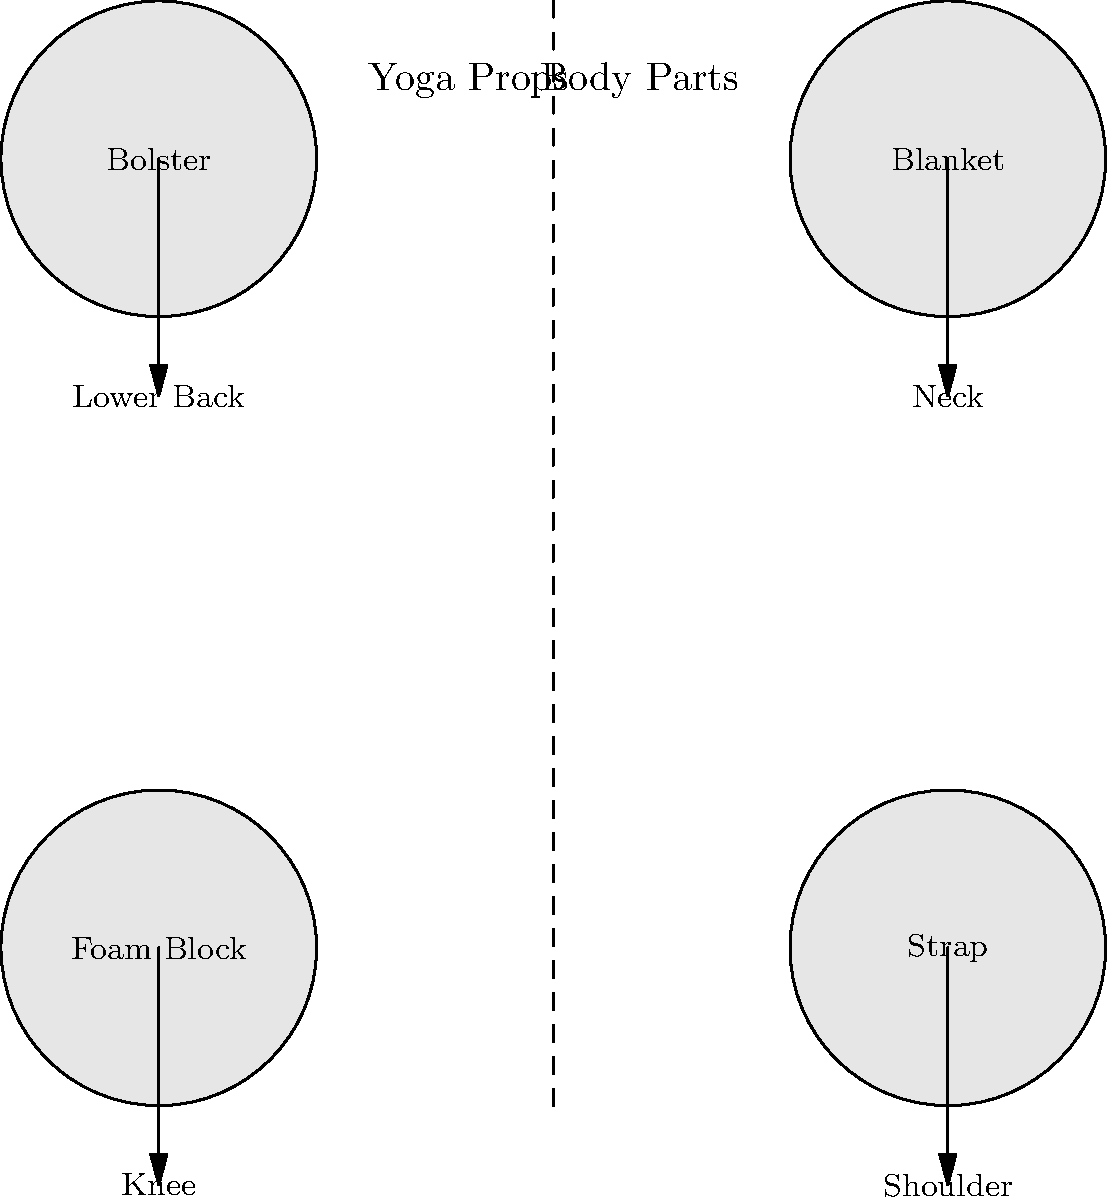Match the yoga props on the left to the corresponding body parts on the right that they are most commonly used to support during injury recovery. Which prop is typically used for lower back support? To answer this question, let's analyze each yoga prop and its typical use in injury recovery:

1. Foam Block: Often used for support in standing poses or to elevate hips in seated poses. It can be helpful for knee injuries by providing stability, but it's not the primary tool for lower back support.

2. Strap: Commonly used to assist in stretches, particularly for shoulders and hamstrings. It's excellent for improving flexibility in the shoulder area during recovery but not typically used for lower back support.

3. Bolster: This long, firm cushion is ideal for supporting the spine in restorative poses. It's frequently placed under the knees or lower back to provide support and promote relaxation. The bolster is the most suitable prop for lower back support among the options given.

4. Blanket: Often folded and used to support the neck in supine poses or to pad joints. While it can be used in various ways, it's not the primary tool for lower back support compared to the bolster.

Given these considerations, the yoga prop most commonly used for lower back support is the bolster.
Answer: Bolster 